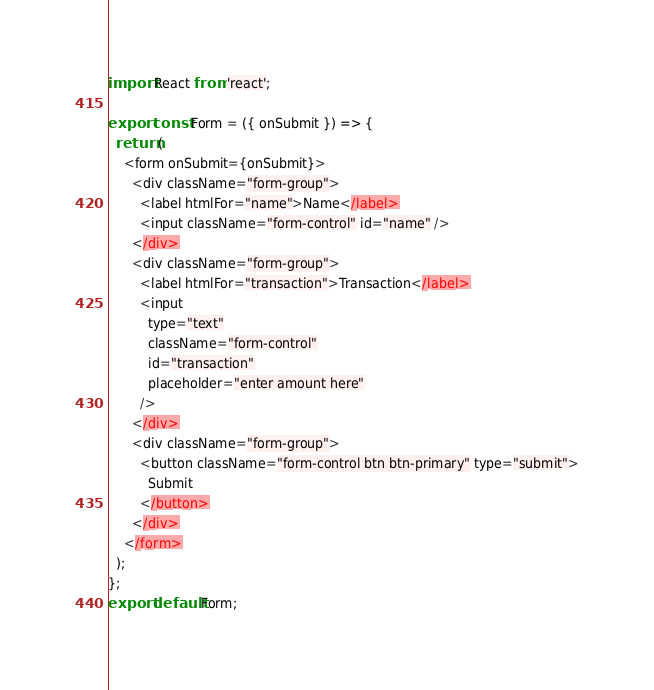<code> <loc_0><loc_0><loc_500><loc_500><_JavaScript_>import React from 'react';

export const Form = ({ onSubmit }) => {
  return (
    <form onSubmit={onSubmit}>
      <div className="form-group">
        <label htmlFor="name">Name</label>
        <input className="form-control" id="name" />
      </div>
      <div className="form-group">
        <label htmlFor="transaction">Transaction</label>
        <input
          type="text"
          className="form-control"
          id="transaction"
          placeholder="enter amount here"
        />
      </div>
      <div className="form-group">
        <button className="form-control btn btn-primary" type="submit">
          Submit
        </button>
      </div>
    </form>
  );
};
export default Form;
</code> 